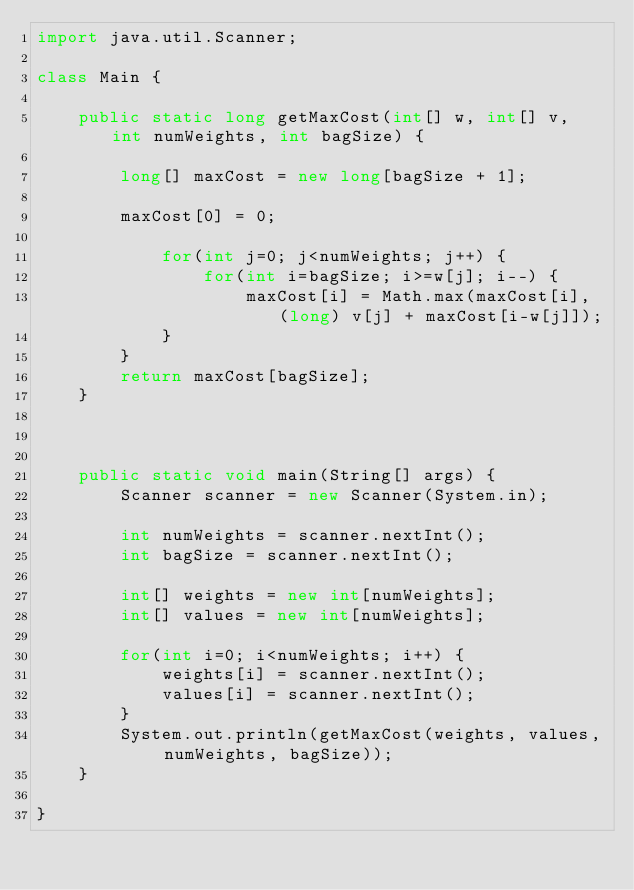Convert code to text. <code><loc_0><loc_0><loc_500><loc_500><_Java_>import java.util.Scanner;

class Main {

    public static long getMaxCost(int[] w, int[] v, int numWeights, int bagSize) {

        long[] maxCost = new long[bagSize + 1];

        maxCost[0] = 0;

            for(int j=0; j<numWeights; j++) {
                for(int i=bagSize; i>=w[j]; i--) {
                    maxCost[i] = Math.max(maxCost[i], (long) v[j] + maxCost[i-w[j]]);
            }
        }
        return maxCost[bagSize];
    }



    public static void main(String[] args) {
        Scanner scanner = new Scanner(System.in);

        int numWeights = scanner.nextInt();
        int bagSize = scanner.nextInt();

        int[] weights = new int[numWeights];
        int[] values = new int[numWeights];

        for(int i=0; i<numWeights; i++) {
            weights[i] = scanner.nextInt();
            values[i] = scanner.nextInt();
        }
        System.out.println(getMaxCost(weights, values, numWeights, bagSize));
    }

}
</code> 